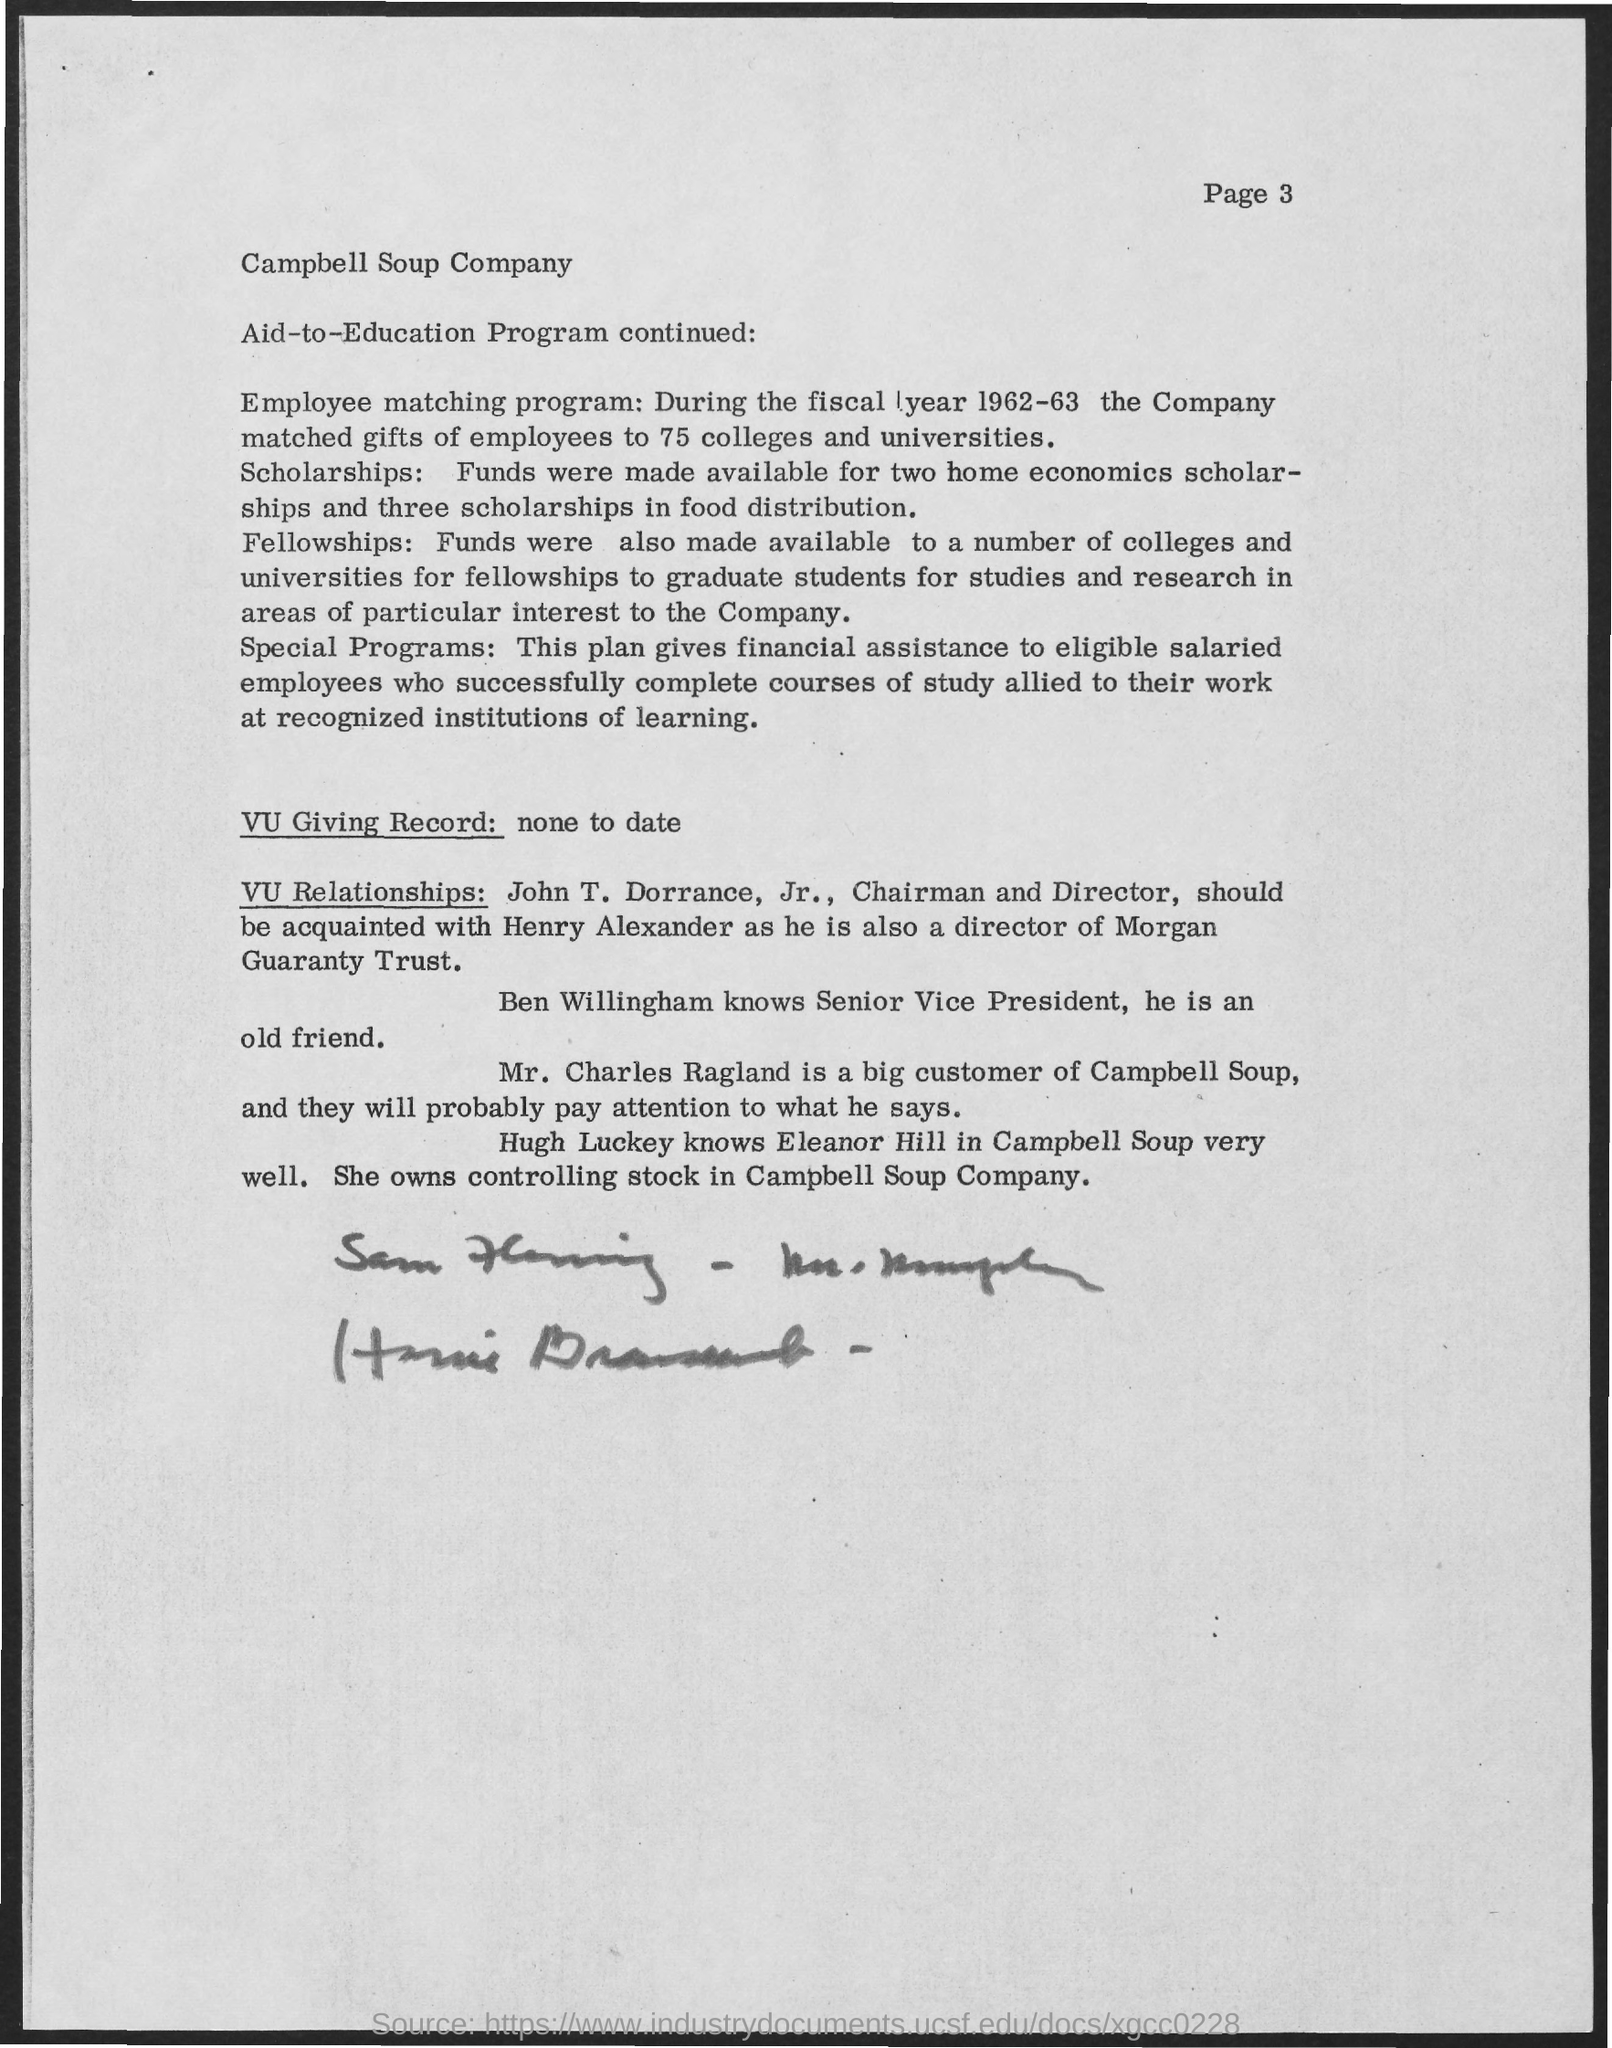Identify some key points in this picture. Campbell Soup has a significant customer named Mr. Charles Ragland who is a big customer of Campbell Soup. The page number is 3, as declared. 